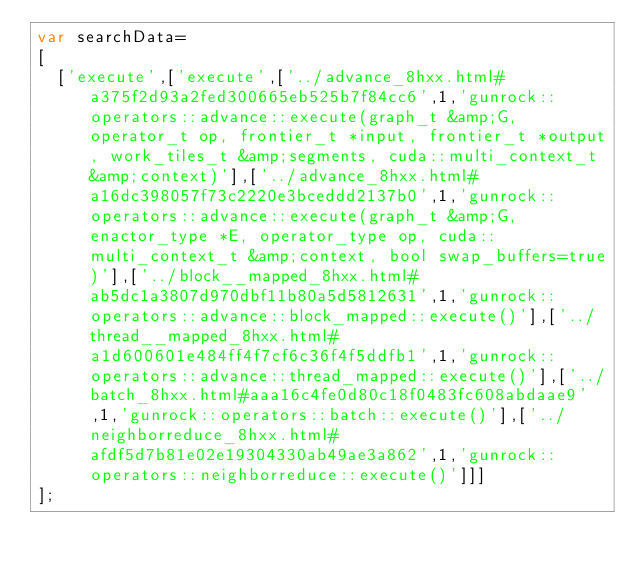Convert code to text. <code><loc_0><loc_0><loc_500><loc_500><_JavaScript_>var searchData=
[
  ['execute',['execute',['../advance_8hxx.html#a375f2d93a2fed300665eb525b7f84cc6',1,'gunrock::operators::advance::execute(graph_t &amp;G, operator_t op, frontier_t *input, frontier_t *output, work_tiles_t &amp;segments, cuda::multi_context_t &amp;context)'],['../advance_8hxx.html#a16dc398057f73c2220e3bceddd2137b0',1,'gunrock::operators::advance::execute(graph_t &amp;G, enactor_type *E, operator_type op, cuda::multi_context_t &amp;context, bool swap_buffers=true)'],['../block__mapped_8hxx.html#ab5dc1a3807d970dbf11b80a5d5812631',1,'gunrock::operators::advance::block_mapped::execute()'],['../thread__mapped_8hxx.html#a1d600601e484ff4f7cf6c36f4f5ddfb1',1,'gunrock::operators::advance::thread_mapped::execute()'],['../batch_8hxx.html#aaa16c4fe0d80c18f0483fc608abdaae9',1,'gunrock::operators::batch::execute()'],['../neighborreduce_8hxx.html#afdf5d7b81e02e19304330ab49ae3a862',1,'gunrock::operators::neighborreduce::execute()']]]
];
</code> 